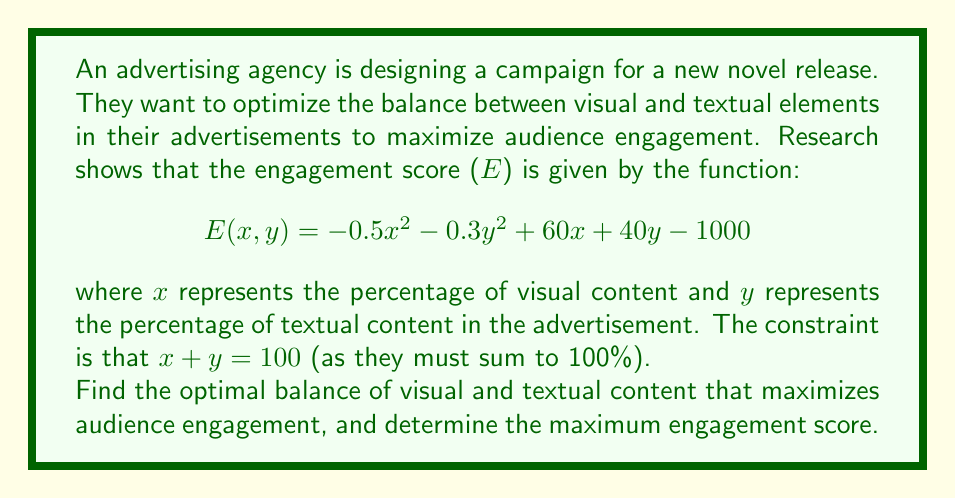Solve this math problem. To solve this optimization problem, we can use the method of Lagrange multipliers, which is particularly suitable for constrained optimization problems.

1. First, let's define our Lagrangian function:
   $$ L(x, y, \lambda) = E(x, y) - \lambda(x + y - 100) $$
   $$ L(x, y, \lambda) = -0.5x^2 - 0.3y^2 + 60x + 40y - 1000 - \lambda(x + y - 100) $$

2. Now, we need to find the partial derivatives and set them to zero:
   $$ \frac{\partial L}{\partial x} = -x + 60 - \lambda = 0 $$
   $$ \frac{\partial L}{\partial y} = -0.6y + 40 - \lambda = 0 $$
   $$ \frac{\partial L}{\partial \lambda} = x + y - 100 = 0 $$

3. From the first equation:
   $$ x = 60 - \lambda $$

4. From the second equation:
   $$ y = \frac{40 - \lambda}{0.6} $$

5. Substituting these into the third equation:
   $$ (60 - \lambda) + \frac{40 - \lambda}{0.6} - 100 = 0 $$

6. Simplifying:
   $$ 60 - \lambda + \frac{66.67 - 1.67\lambda}{1} - 100 = 0 $$
   $$ 26.67 - 2.67\lambda = 0 $$
   $$ \lambda = 10 $$

7. Now we can find x and y:
   $$ x = 60 - 10 = 50 $$
   $$ y = \frac{40 - 10}{0.6} = 50 $$

8. To find the maximum engagement score, we substitute these values back into the original function:
   $$ E(50, 50) = -0.5(50)^2 - 0.3(50)^2 + 60(50) + 40(50) - 1000 $$
   $$ = -1250 - 750 + 3000 + 2000 - 1000 $$
   $$ = 2000 $$

This solution aligns with the literary critic's perspective, as it demonstrates how the balance between visual (akin to "showing" in literature) and textual (akin to "telling" in literature) elements can be optimized for maximum engagement, much like how authors must balance descriptive and narrative elements in their storytelling.
Answer: The optimal balance is 50% visual content and 50% textual content. The maximum engagement score is 2000. 